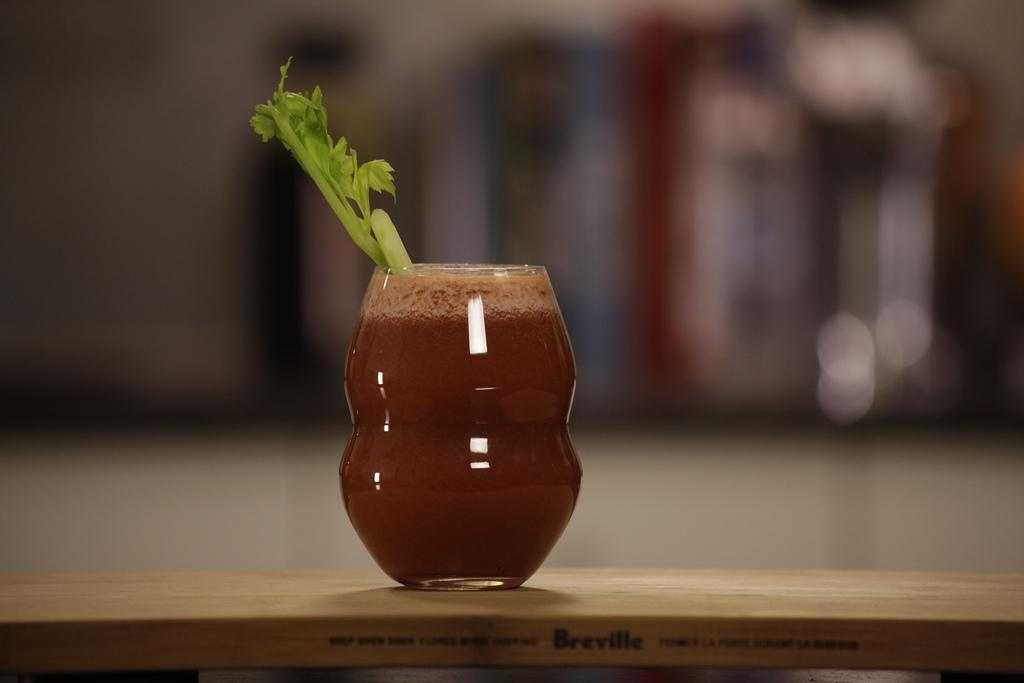What is in the glass that is visible in the image? There is a glass of juice in the image. What is inside the glass? There is a stem in the glass. What color are the eyes of the person holding the glass in the image? There is no person holding the glass in the image, so we cannot determine the color of their eyes. 